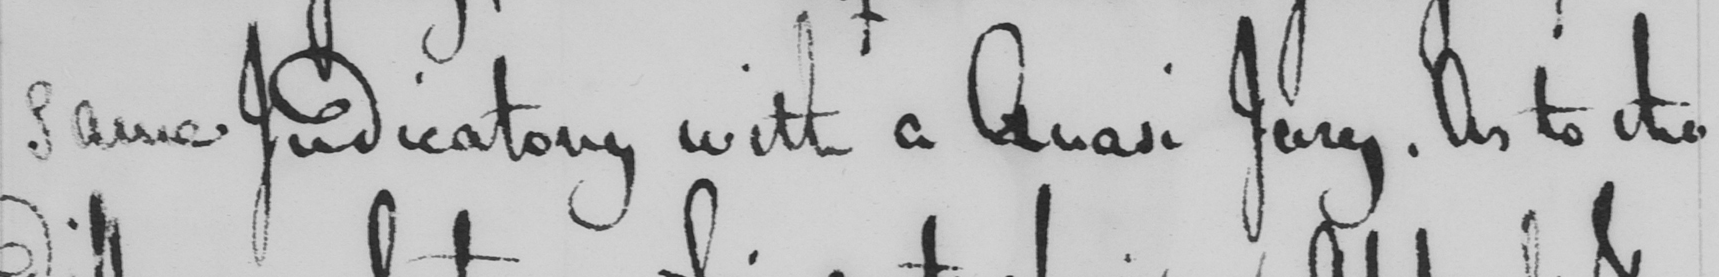Can you tell me what this handwritten text says? same Judicatory with a Quasi Jury . As to the 